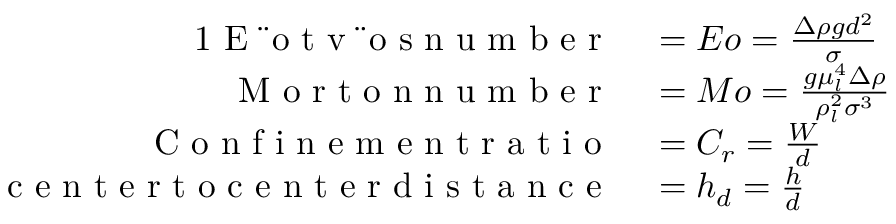Convert formula to latex. <formula><loc_0><loc_0><loc_500><loc_500>\begin{array} { r l } { { 1 } E \ " o t v \ " o s n u m b e r } & = E o = \frac { \Delta \rho g d ^ { 2 } } { \sigma } } \\ { M o r t o n n u m b e r } & = M o = \frac { g \mu _ { l } ^ { 4 } \Delta \rho } { \rho _ { l } ^ { 2 } \sigma ^ { 3 } } } \\ { C o n f i n e m e n t r a t i o } & = C _ { r } = \frac { W } { d } } \\ { c e n t e r t o c e n t e r d i s t a n c e } & = h _ { d } = \frac { h } { d } } \end{array}</formula> 